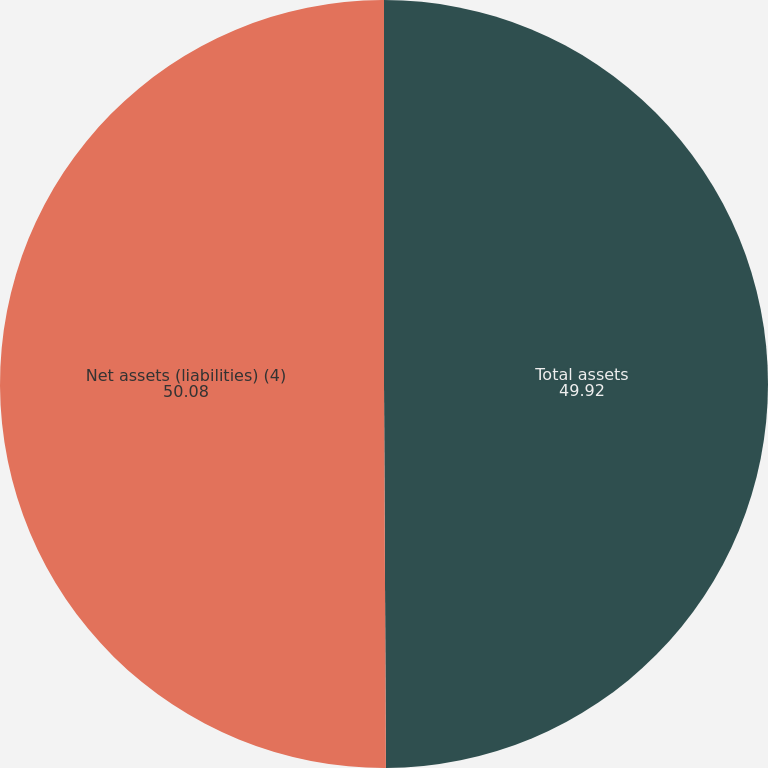Convert chart to OTSL. <chart><loc_0><loc_0><loc_500><loc_500><pie_chart><fcel>Total assets<fcel>Net assets (liabilities) (4)<nl><fcel>49.92%<fcel>50.08%<nl></chart> 